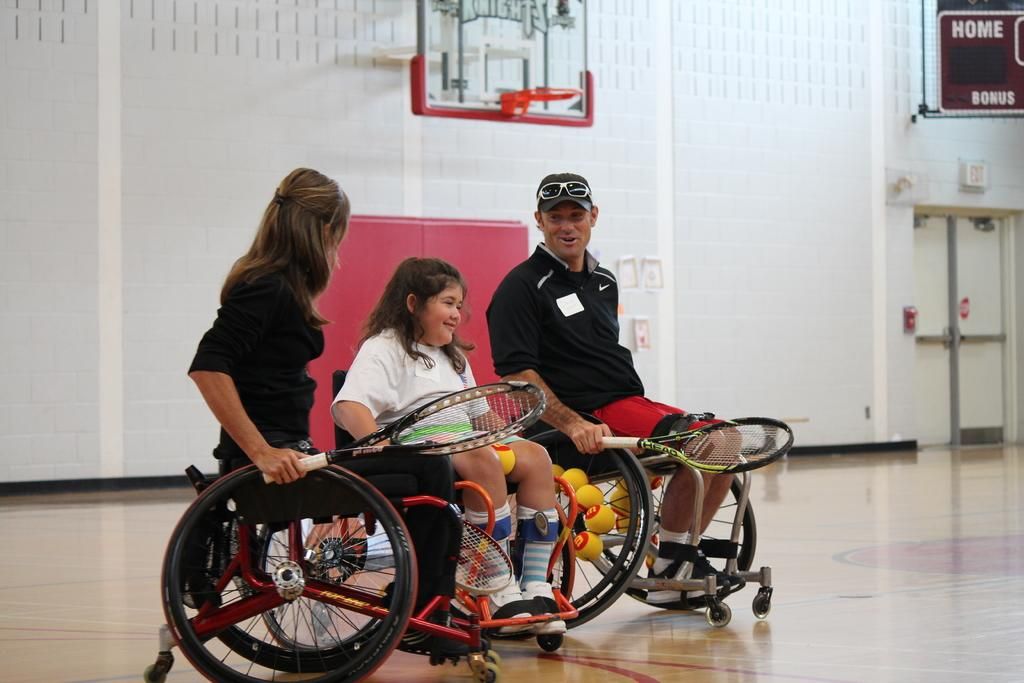What are the people in the image doing? The people in the image are sitting on wheelchairs and holding tennis rackets. What can be seen in the background of the image? There is a wall in the background of the image. Is there anything attached to the wall? Yes, there is a board attached to the wall. Where is the sofa located in the image? There is no sofa present in the image. What type of lunch is being served to the people in the image? There is no lunch being served in the image; the people are holding tennis rackets. 